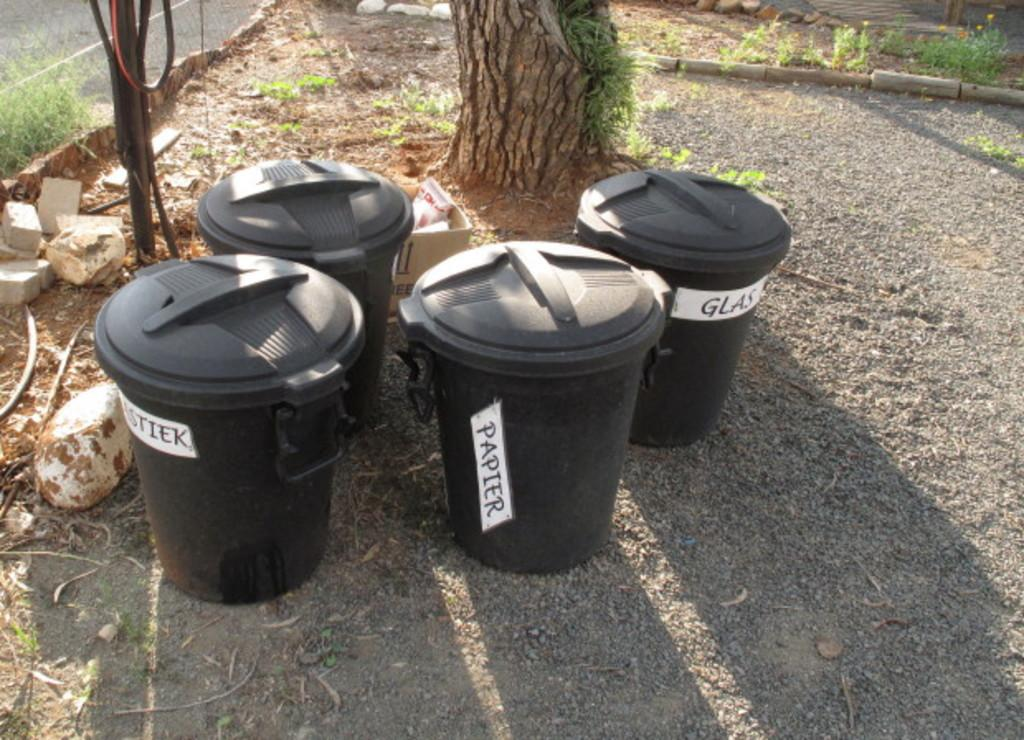Provide a one-sentence caption for the provided image. Four black garbage pails are labeled for paper and glass. 